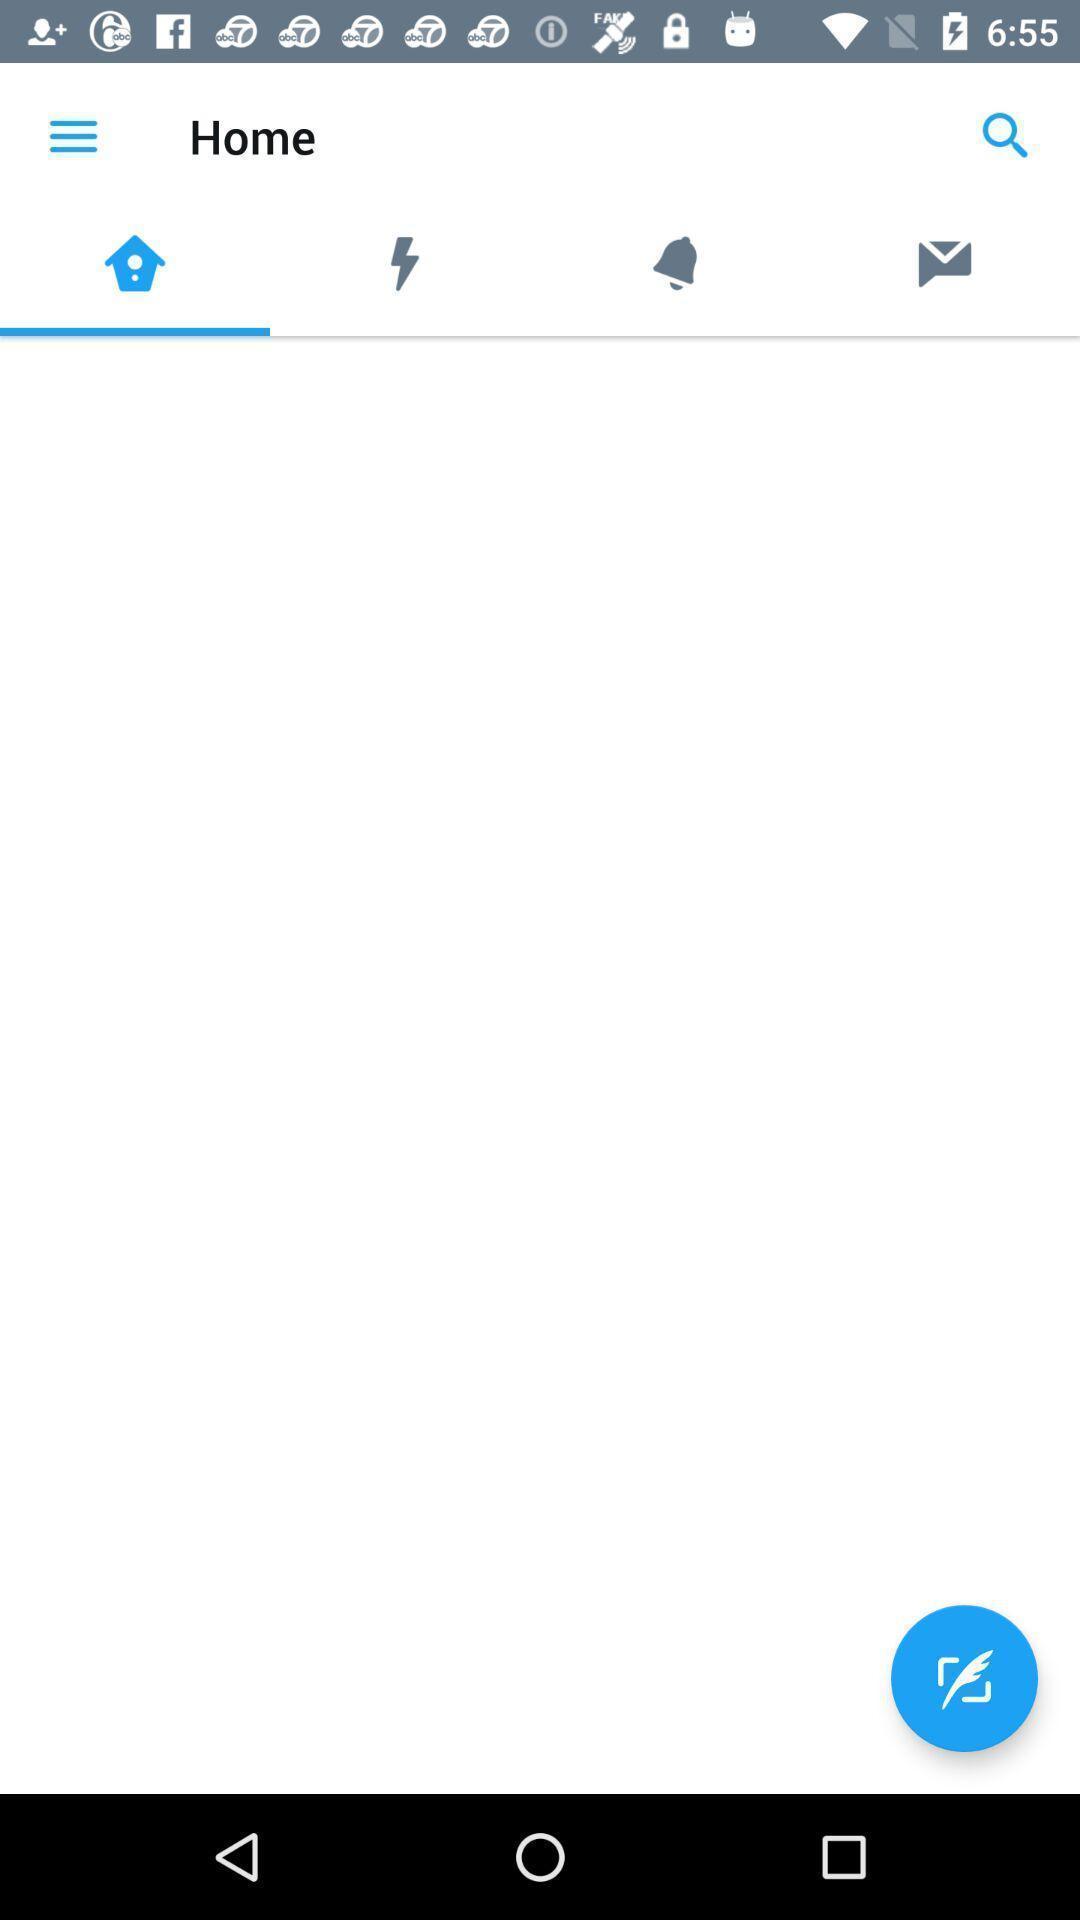Summarize the information in this screenshot. Screen shows home page of a social application. 